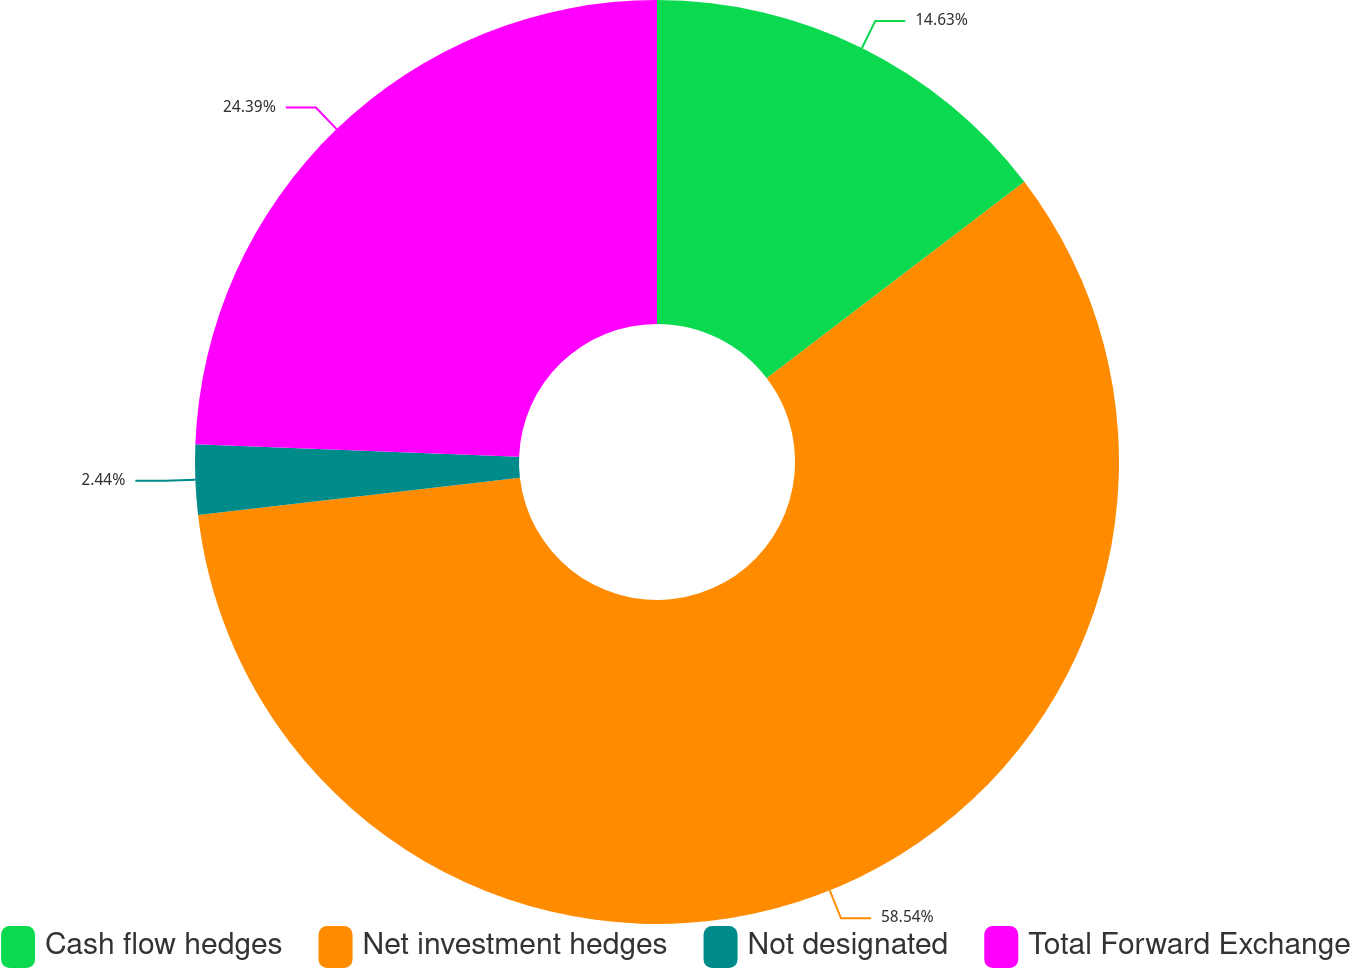<chart> <loc_0><loc_0><loc_500><loc_500><pie_chart><fcel>Cash flow hedges<fcel>Net investment hedges<fcel>Not designated<fcel>Total Forward Exchange<nl><fcel>14.63%<fcel>58.54%<fcel>2.44%<fcel>24.39%<nl></chart> 